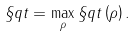Convert formula to latex. <formula><loc_0><loc_0><loc_500><loc_500>\S q t = \max _ { \rho } \S q t \left ( \rho \right ) .</formula> 